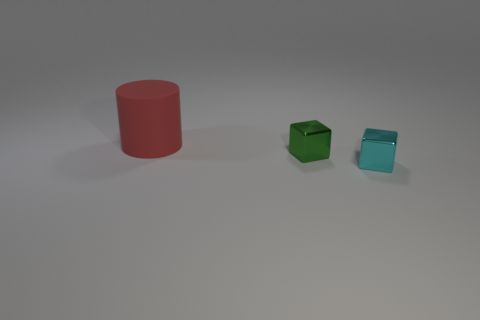Subtract all blue blocks. Subtract all cyan spheres. How many blocks are left? 2 Add 2 green metal cubes. How many objects exist? 5 Subtract all cylinders. How many objects are left? 2 Subtract 0 brown cylinders. How many objects are left? 3 Subtract all red things. Subtract all large blue cylinders. How many objects are left? 2 Add 1 cyan blocks. How many cyan blocks are left? 2 Add 2 gray metal balls. How many gray metal balls exist? 2 